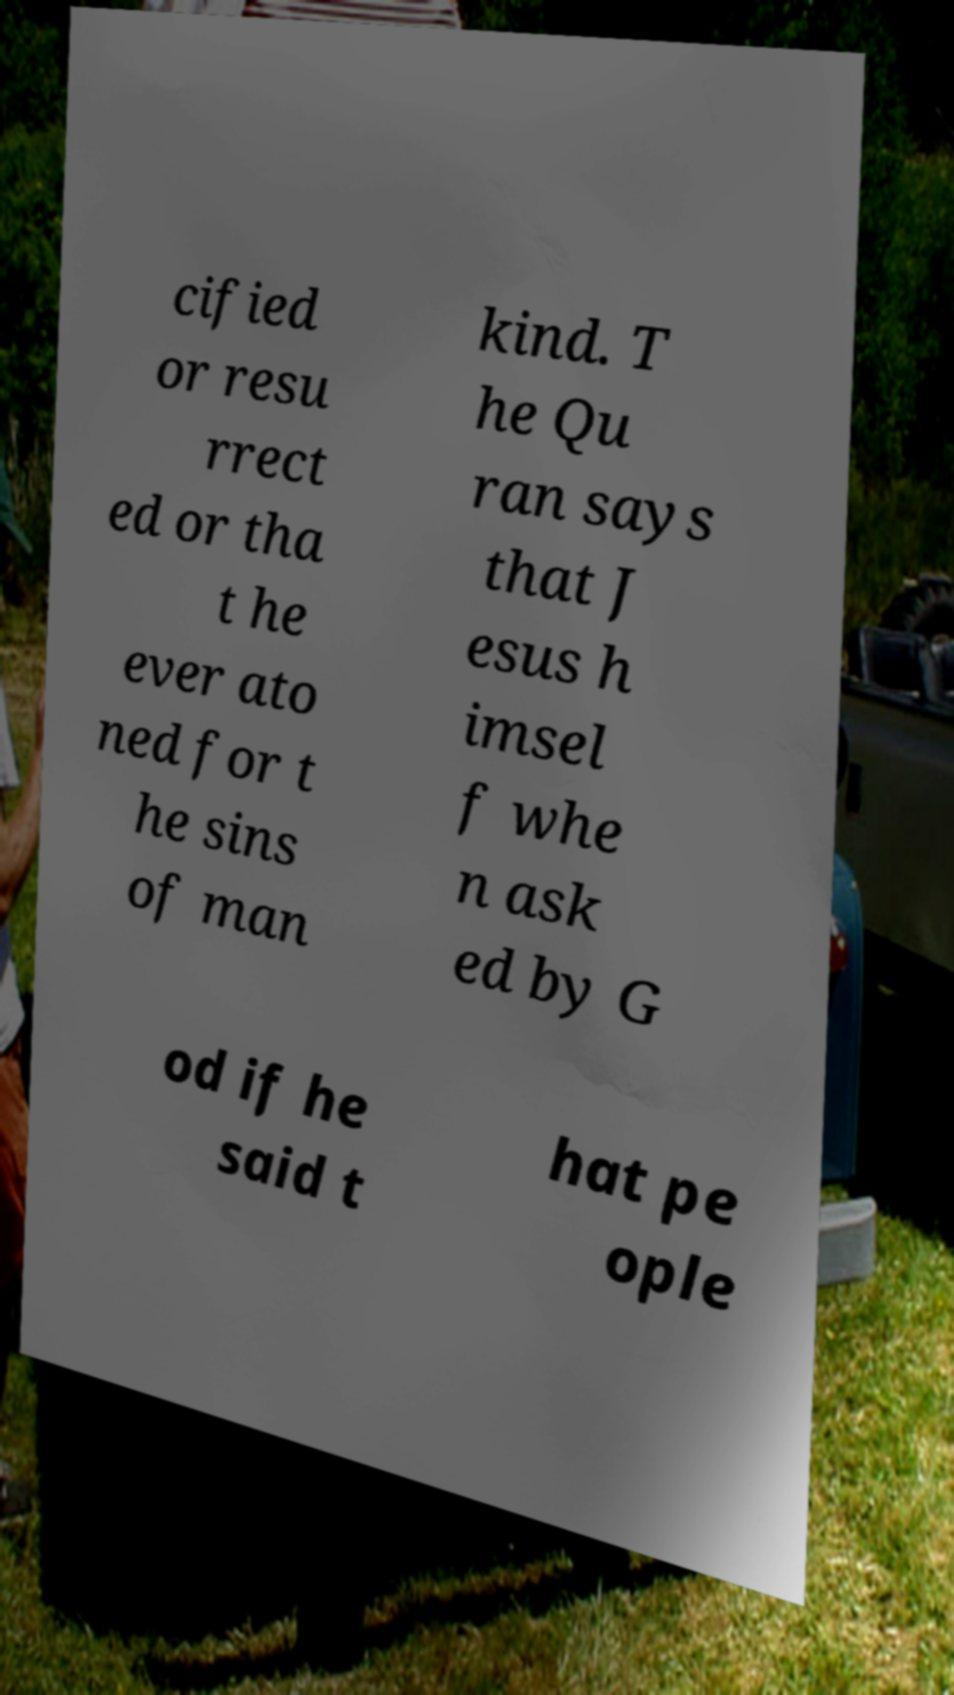Can you read and provide the text displayed in the image?This photo seems to have some interesting text. Can you extract and type it out for me? cified or resu rrect ed or tha t he ever ato ned for t he sins of man kind. T he Qu ran says that J esus h imsel f whe n ask ed by G od if he said t hat pe ople 